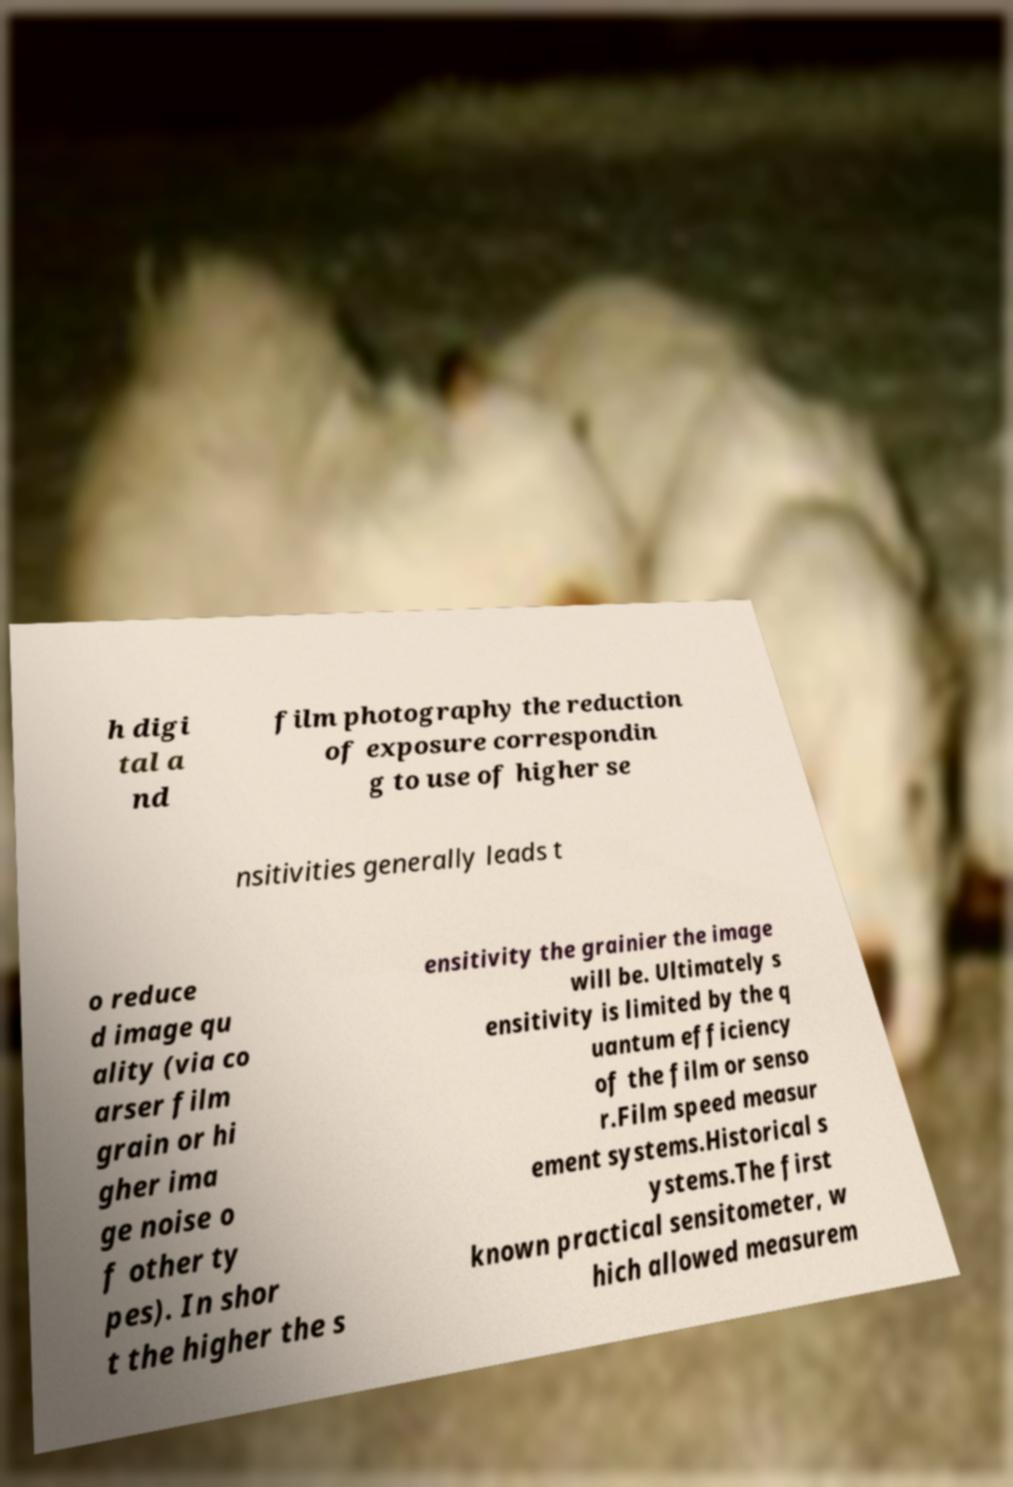Please identify and transcribe the text found in this image. h digi tal a nd film photography the reduction of exposure correspondin g to use of higher se nsitivities generally leads t o reduce d image qu ality (via co arser film grain or hi gher ima ge noise o f other ty pes). In shor t the higher the s ensitivity the grainier the image will be. Ultimately s ensitivity is limited by the q uantum efficiency of the film or senso r.Film speed measur ement systems.Historical s ystems.The first known practical sensitometer, w hich allowed measurem 